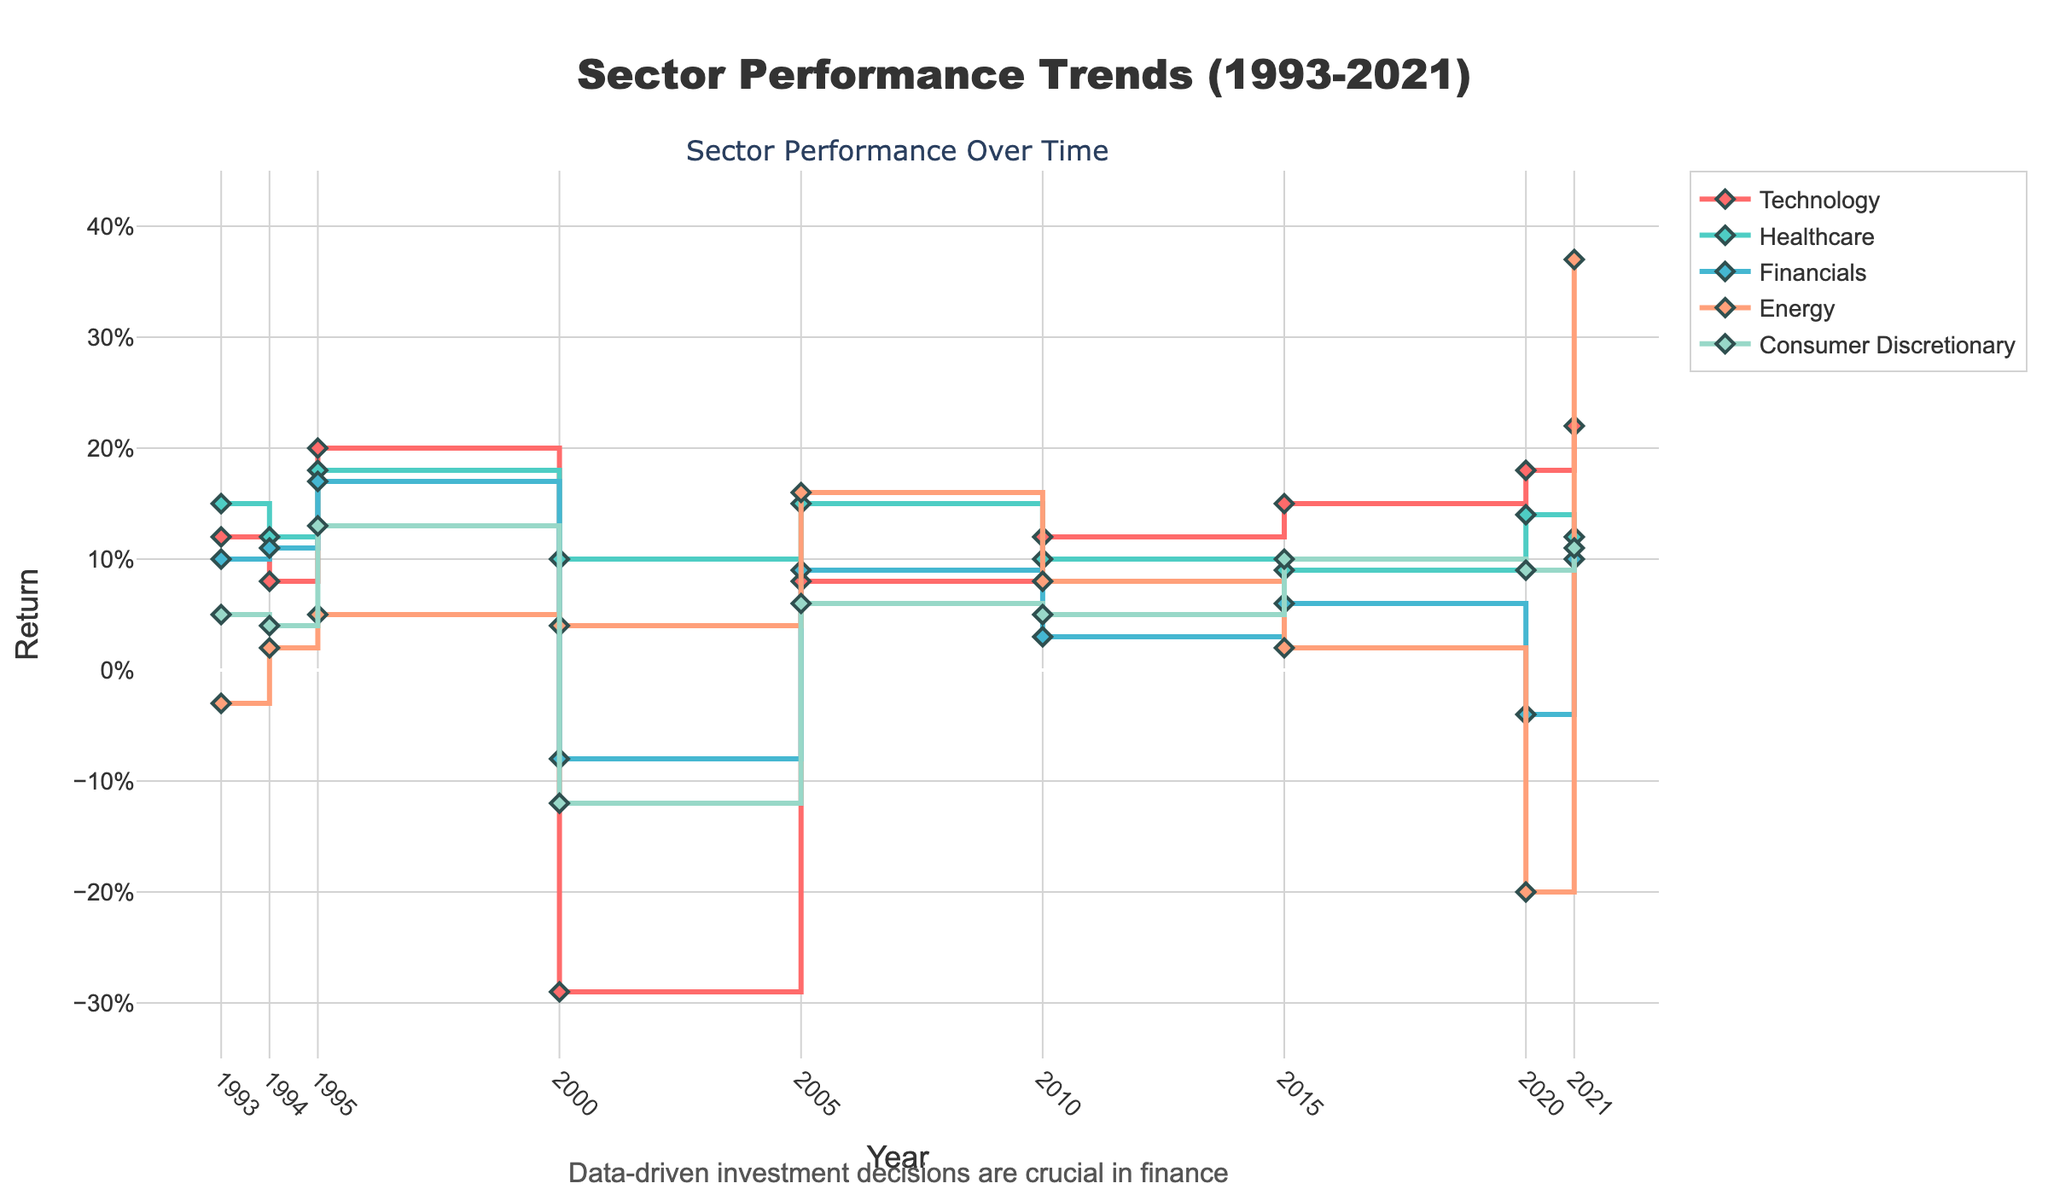what is the title of the plot? The title of the plot is displayed at the top center of the figure. It reads 'Sector Performance Trends (1993-2021)'.
Answer: Sector Performance Trends (1993-2021) How many sectors are displayed in the plot? Each sector is represented by a distinct line in the plot. By counting the lines in the legend, we can identify five sectors.
Answer: Five What color is used to represent the Technology sector? The color of each sector's line is consistent with the legend. For the Technology sector, the line color is red.
Answer: Red Which sector had the highest return in 2021 and what was it? By observing the data points for 2021, one sector has a notable spike. The line for Energy peaks at the highest point on the y-axis in 2021.
Answer: Energy, 0.37 How did the returns of Financials change from 1993 to 2021? Identify the points on the Financials line at 1993 and 2021. The line starts at 0.10 in 1993 and ends at 0.10 in 2021, suggesting no net change.
Answer: No net change What was the average return of Technology across all plotted years? By adding up the returns of 0.12 (1993) + 0.08 (1994) + 0.20 (1995) + (-0.29) (2000) + 0.08 (2005) + 0.12 (2010) + 0.15 (2015) + 0.18 (2020) + 0.22 (2021) and then dividing by 9, we get the average return.
Answer: 0.10 Which year had the most significant negative return for the Technology sector? By locating the lowest point on the Technology sector line, we see the largest drop occurs in the year 2000.
Answer: 2000 Compare the highest return for Technology and Healthcare sectors in 2021. Which was higher and by how much? Identify the 2021 data points for both sectors: Technology at 0.22 and Healthcare at 0.12. The difference is 0.22 - 0.12 = 0.10.
Answer: Technology, by 0.10 Which sector showed a negative return in 2020? By observing the 2020 data points, both Financials and Energy show negative returns.
Answer: Financials and Energy Between 1993 and 2021, which sector showed the highest consistency in returns? By analyzing the fluctuations in each sector's line, Healthcare shows the least variation, indicating consistency.
Answer: Healthcare 